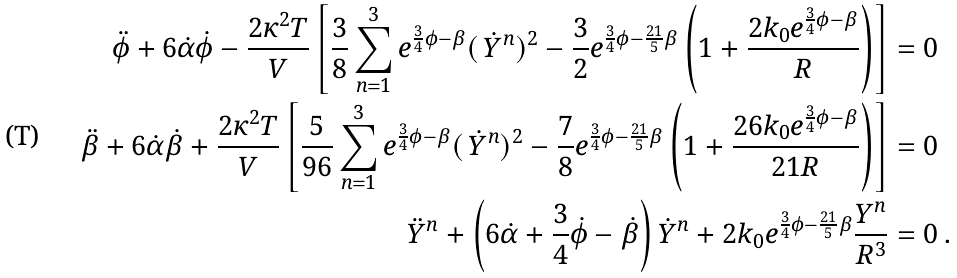Convert formula to latex. <formula><loc_0><loc_0><loc_500><loc_500>\ddot { \phi } + 6 \dot { \alpha } \dot { \phi } - \frac { 2 \kappa ^ { 2 } T } { V } \left [ \frac { 3 } { 8 } \sum _ { n = 1 } ^ { 3 } e ^ { \frac { 3 } { 4 } \phi - \beta } ( \, \dot { Y } ^ { n } ) ^ { 2 } - \frac { 3 } { 2 } e ^ { \frac { 3 } { 4 } \phi - \frac { 2 1 } { 5 } \beta } \left ( 1 + \frac { 2 k _ { 0 } e ^ { \frac { 3 } { 4 } \phi - \beta } } { R } \right ) \right ] & = 0 \\ \ddot { \beta } + 6 \dot { \alpha } \dot { \beta } + \frac { 2 \kappa ^ { 2 } T } { V } \left [ \frac { 5 } { 9 6 } \sum _ { n = 1 } ^ { 3 } e ^ { \frac { 3 } { 4 } \phi - \beta } ( \, \dot { Y } ^ { n } ) ^ { 2 } - \frac { 7 } { 8 } e ^ { \frac { 3 } { 4 } \phi - \frac { 2 1 } { 5 } \beta } \left ( 1 + \frac { 2 6 k _ { 0 } e ^ { \frac { 3 } { 4 } \phi - \beta } } { 2 1 R } \right ) \right ] & = 0 \\ \ddot { Y } ^ { n } + \left ( 6 \dot { \alpha } + \frac { 3 } { 4 } \dot { \phi } - \dot { \beta } \right ) \dot { Y } ^ { n } + 2 k _ { 0 } e ^ { \frac { 3 } { 4 } \phi - \frac { 2 1 } { 5 } \beta } \frac { Y ^ { n } } { R ^ { 3 } } & = 0 \, .</formula> 